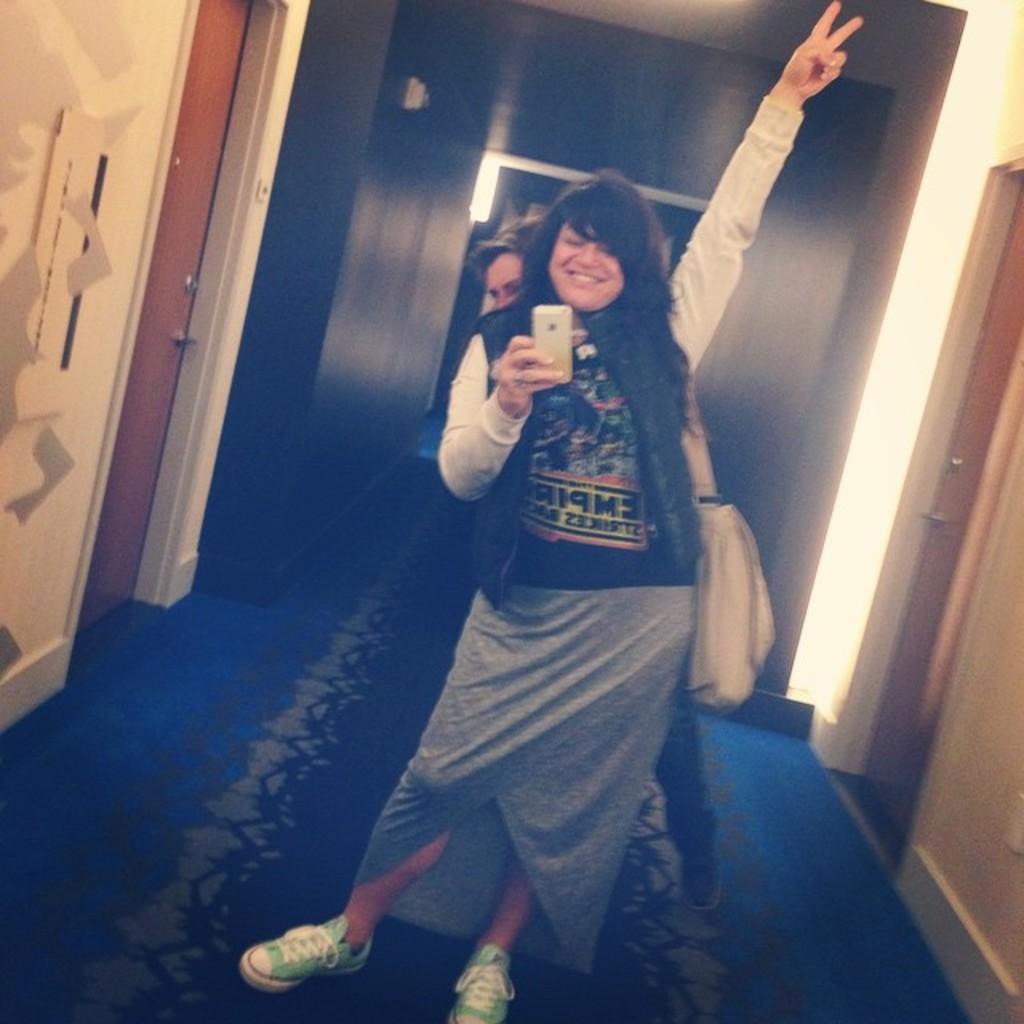Can you describe this image briefly? In this image I can see two persons are standing and here I can see smile on her face. I can also see she is carrying a bag and she is holding a phone. In the background I can see doors and here I can see something is written on her dress. 